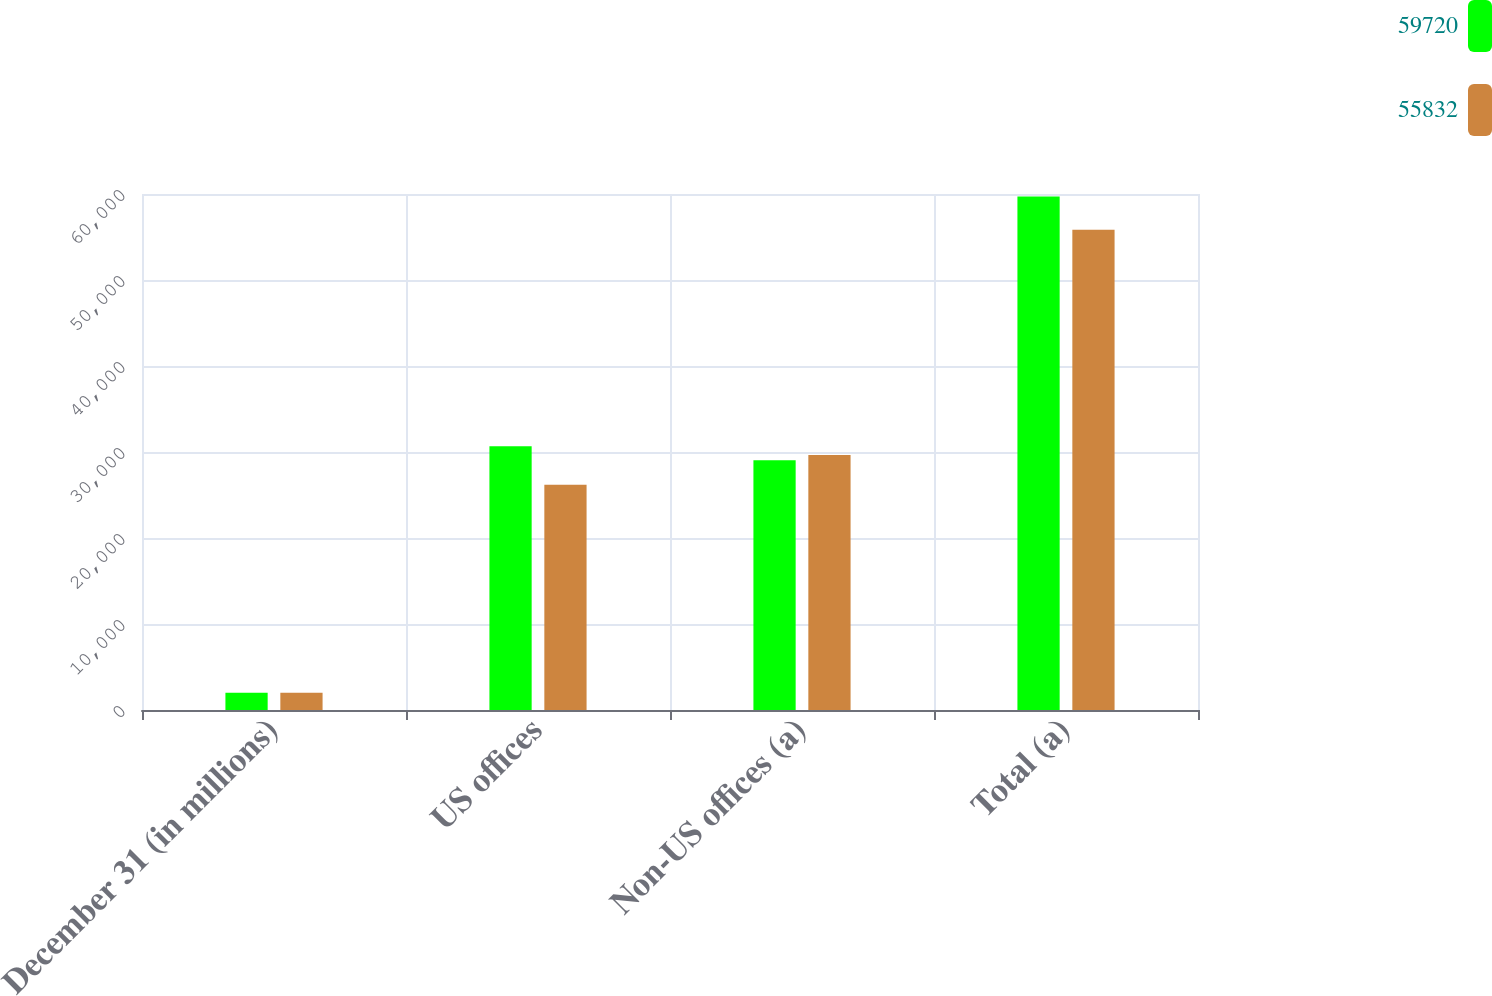Convert chart. <chart><loc_0><loc_0><loc_500><loc_500><stacked_bar_chart><ecel><fcel>December 31 (in millions)<fcel>US offices<fcel>Non-US offices (a)<fcel>Total (a)<nl><fcel>59720<fcel>2017<fcel>30671<fcel>29049<fcel>59720<nl><fcel>55832<fcel>2016<fcel>26180<fcel>29652<fcel>55832<nl></chart> 